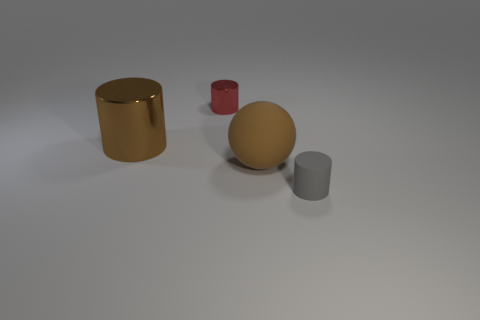There is a thing that is right of the large shiny cylinder and behind the large sphere; what size is it?
Make the answer very short. Small. Do the big cylinder and the matte object that is left of the small gray object have the same color?
Provide a short and direct response. Yes. What number of brown things are large metal objects or tiny cylinders?
Make the answer very short. 1. What is the shape of the tiny matte object?
Your response must be concise. Cylinder. How many other objects are there of the same shape as the brown rubber thing?
Offer a terse response. 0. There is a tiny cylinder behind the tiny gray object; what color is it?
Offer a very short reply. Red. Is the gray thing made of the same material as the big brown cylinder?
Your answer should be compact. No. What number of objects are either small blue metal cubes or cylinders to the right of the brown ball?
Keep it short and to the point. 1. What size is the object that is the same color as the large cylinder?
Provide a short and direct response. Large. What shape is the small thing left of the gray matte object?
Offer a terse response. Cylinder. 